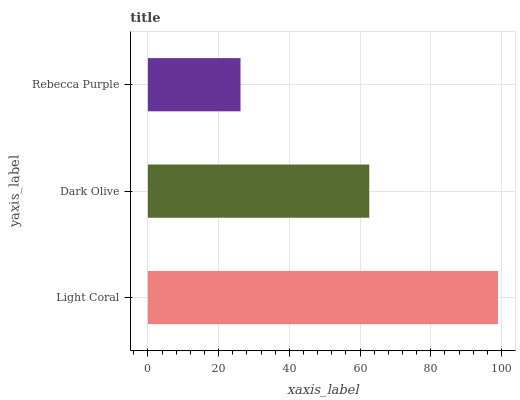Is Rebecca Purple the minimum?
Answer yes or no. Yes. Is Light Coral the maximum?
Answer yes or no. Yes. Is Dark Olive the minimum?
Answer yes or no. No. Is Dark Olive the maximum?
Answer yes or no. No. Is Light Coral greater than Dark Olive?
Answer yes or no. Yes. Is Dark Olive less than Light Coral?
Answer yes or no. Yes. Is Dark Olive greater than Light Coral?
Answer yes or no. No. Is Light Coral less than Dark Olive?
Answer yes or no. No. Is Dark Olive the high median?
Answer yes or no. Yes. Is Dark Olive the low median?
Answer yes or no. Yes. Is Light Coral the high median?
Answer yes or no. No. Is Light Coral the low median?
Answer yes or no. No. 